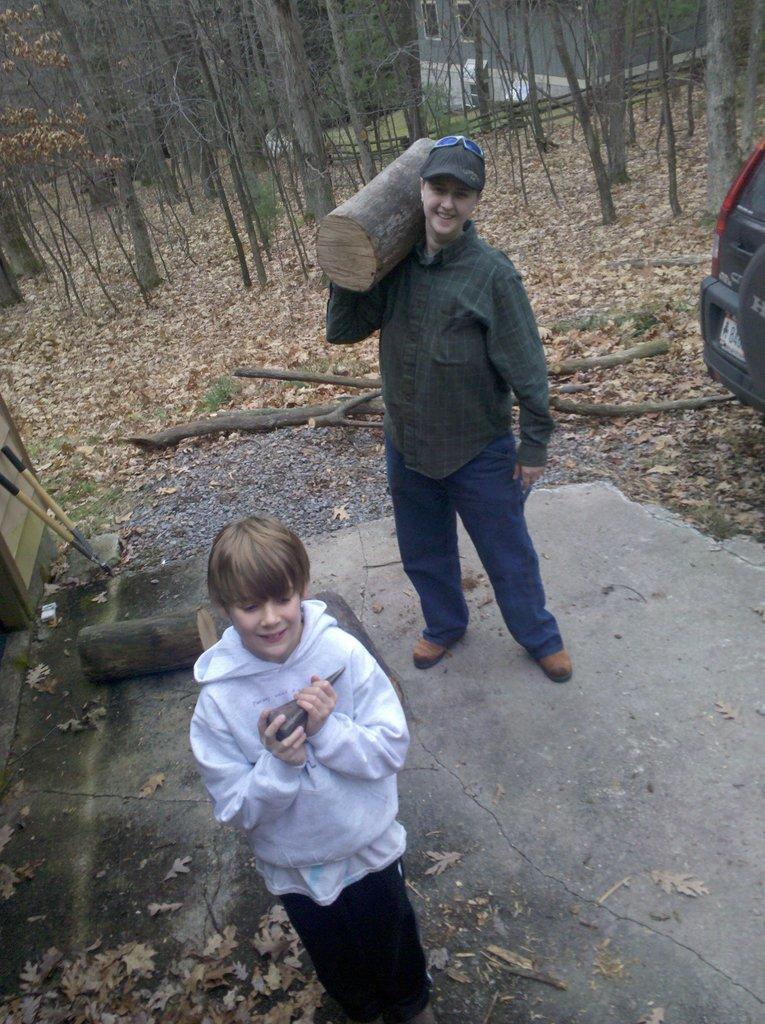Could you give a brief overview of what you see in this image? In this picture we can see there are two persons standing and a man is holding a wooden log. On the right side of the image there is a vehicle. On the left side of the image, there are sticks and another wooden log. Behind the people there are trees, dried leaves and a house. 